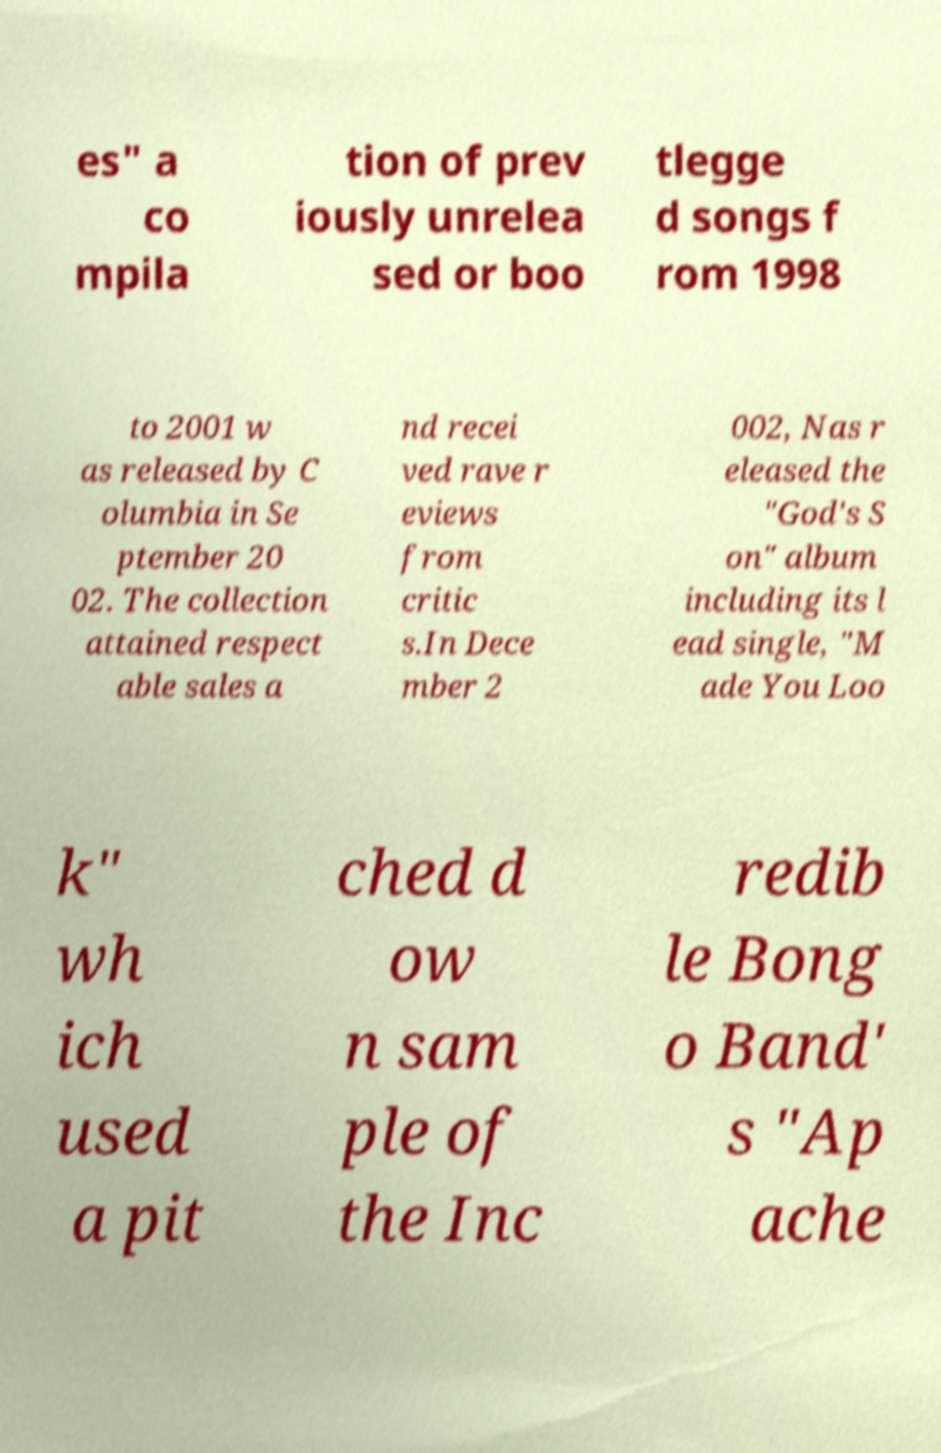What messages or text are displayed in this image? I need them in a readable, typed format. es" a co mpila tion of prev iously unrelea sed or boo tlegge d songs f rom 1998 to 2001 w as released by C olumbia in Se ptember 20 02. The collection attained respect able sales a nd recei ved rave r eviews from critic s.In Dece mber 2 002, Nas r eleased the "God's S on" album including its l ead single, "M ade You Loo k" wh ich used a pit ched d ow n sam ple of the Inc redib le Bong o Band' s "Ap ache 